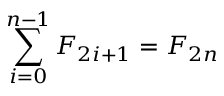<formula> <loc_0><loc_0><loc_500><loc_500>\sum _ { i = 0 } ^ { n - 1 } F _ { 2 i + 1 } = F _ { 2 n }</formula> 